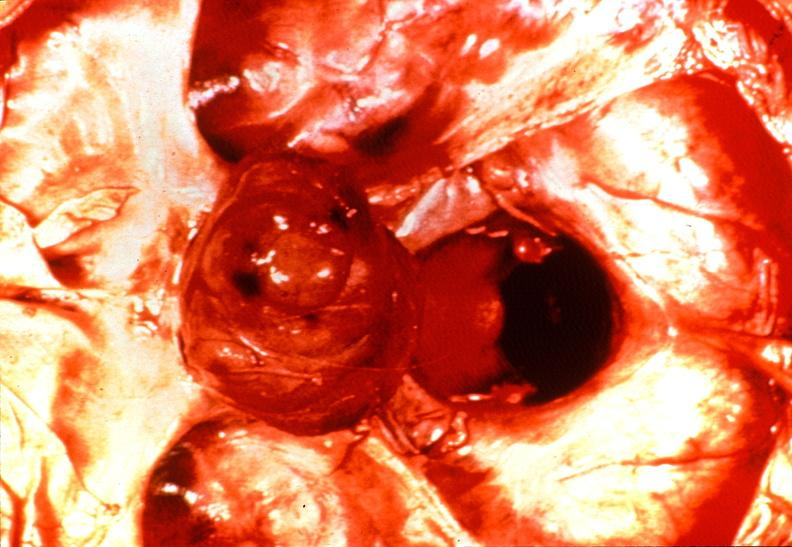s aldehyde fuscin present?
Answer the question using a single word or phrase. No 